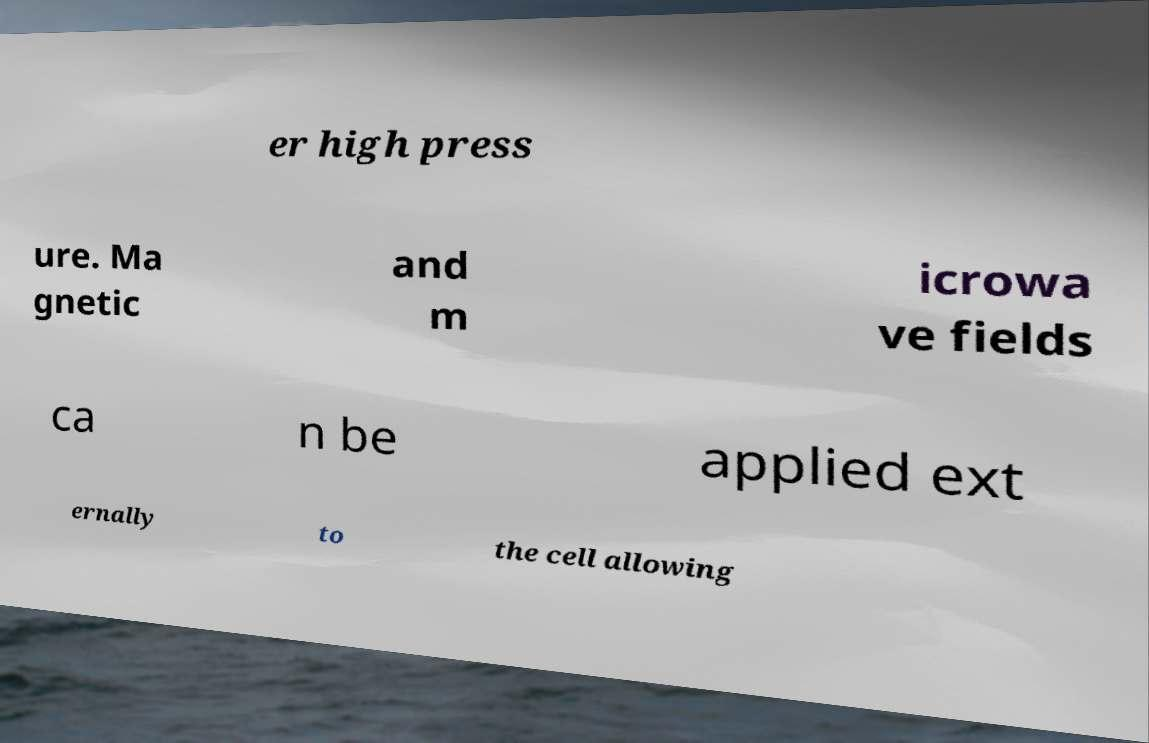Can you read and provide the text displayed in the image?This photo seems to have some interesting text. Can you extract and type it out for me? er high press ure. Ma gnetic and m icrowa ve fields ca n be applied ext ernally to the cell allowing 